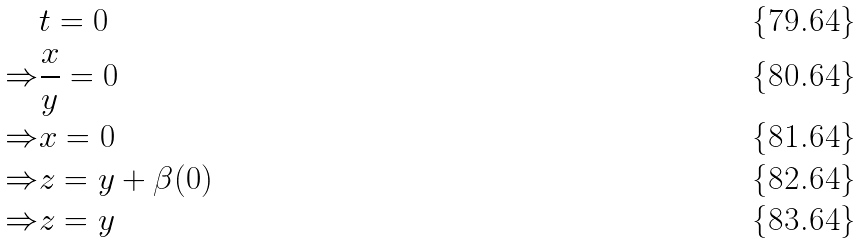<formula> <loc_0><loc_0><loc_500><loc_500>& t = 0 \\ \Rightarrow & \frac { x } { y } = 0 \\ \Rightarrow & x = 0 \\ \Rightarrow & z = y + \beta ( 0 ) \\ \Rightarrow & z = y</formula> 